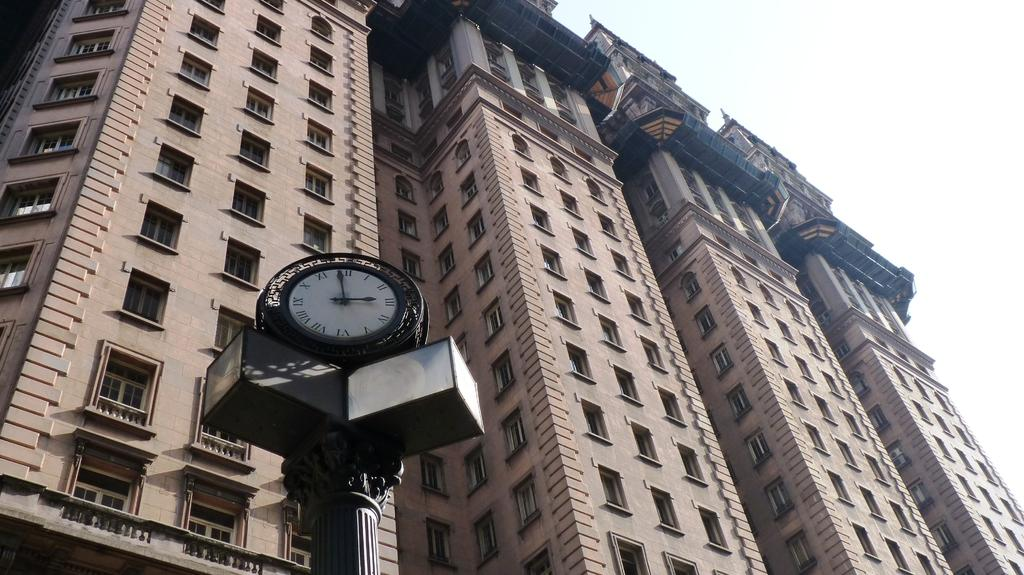What structures are located in the foreground of the image? There are buildings and a clock pole in the foreground of the image. Can you describe the background of the image? The sky is visible in the background of the image. What type of cabbage is being used to decorate the clock pole in the image? There is no cabbage present in the image, and the clock pole is not being used for decoration. 